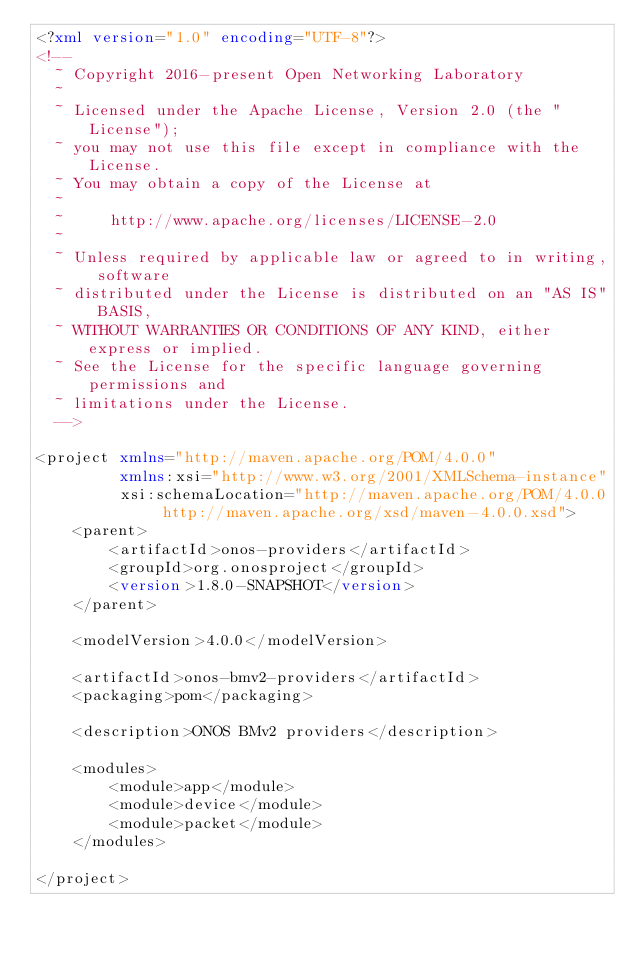Convert code to text. <code><loc_0><loc_0><loc_500><loc_500><_XML_><?xml version="1.0" encoding="UTF-8"?>
<!--
  ~ Copyright 2016-present Open Networking Laboratory
  ~
  ~ Licensed under the Apache License, Version 2.0 (the "License");
  ~ you may not use this file except in compliance with the License.
  ~ You may obtain a copy of the License at
  ~
  ~     http://www.apache.org/licenses/LICENSE-2.0
  ~
  ~ Unless required by applicable law or agreed to in writing, software
  ~ distributed under the License is distributed on an "AS IS" BASIS,
  ~ WITHOUT WARRANTIES OR CONDITIONS OF ANY KIND, either express or implied.
  ~ See the License for the specific language governing permissions and
  ~ limitations under the License.
  -->

<project xmlns="http://maven.apache.org/POM/4.0.0"
         xmlns:xsi="http://www.w3.org/2001/XMLSchema-instance"
         xsi:schemaLocation="http://maven.apache.org/POM/4.0.0 http://maven.apache.org/xsd/maven-4.0.0.xsd">
    <parent>
        <artifactId>onos-providers</artifactId>
        <groupId>org.onosproject</groupId>
        <version>1.8.0-SNAPSHOT</version>
    </parent>

    <modelVersion>4.0.0</modelVersion>

    <artifactId>onos-bmv2-providers</artifactId>
    <packaging>pom</packaging>

    <description>ONOS BMv2 providers</description>

    <modules>
        <module>app</module>
        <module>device</module>
        <module>packet</module>
    </modules>

</project></code> 